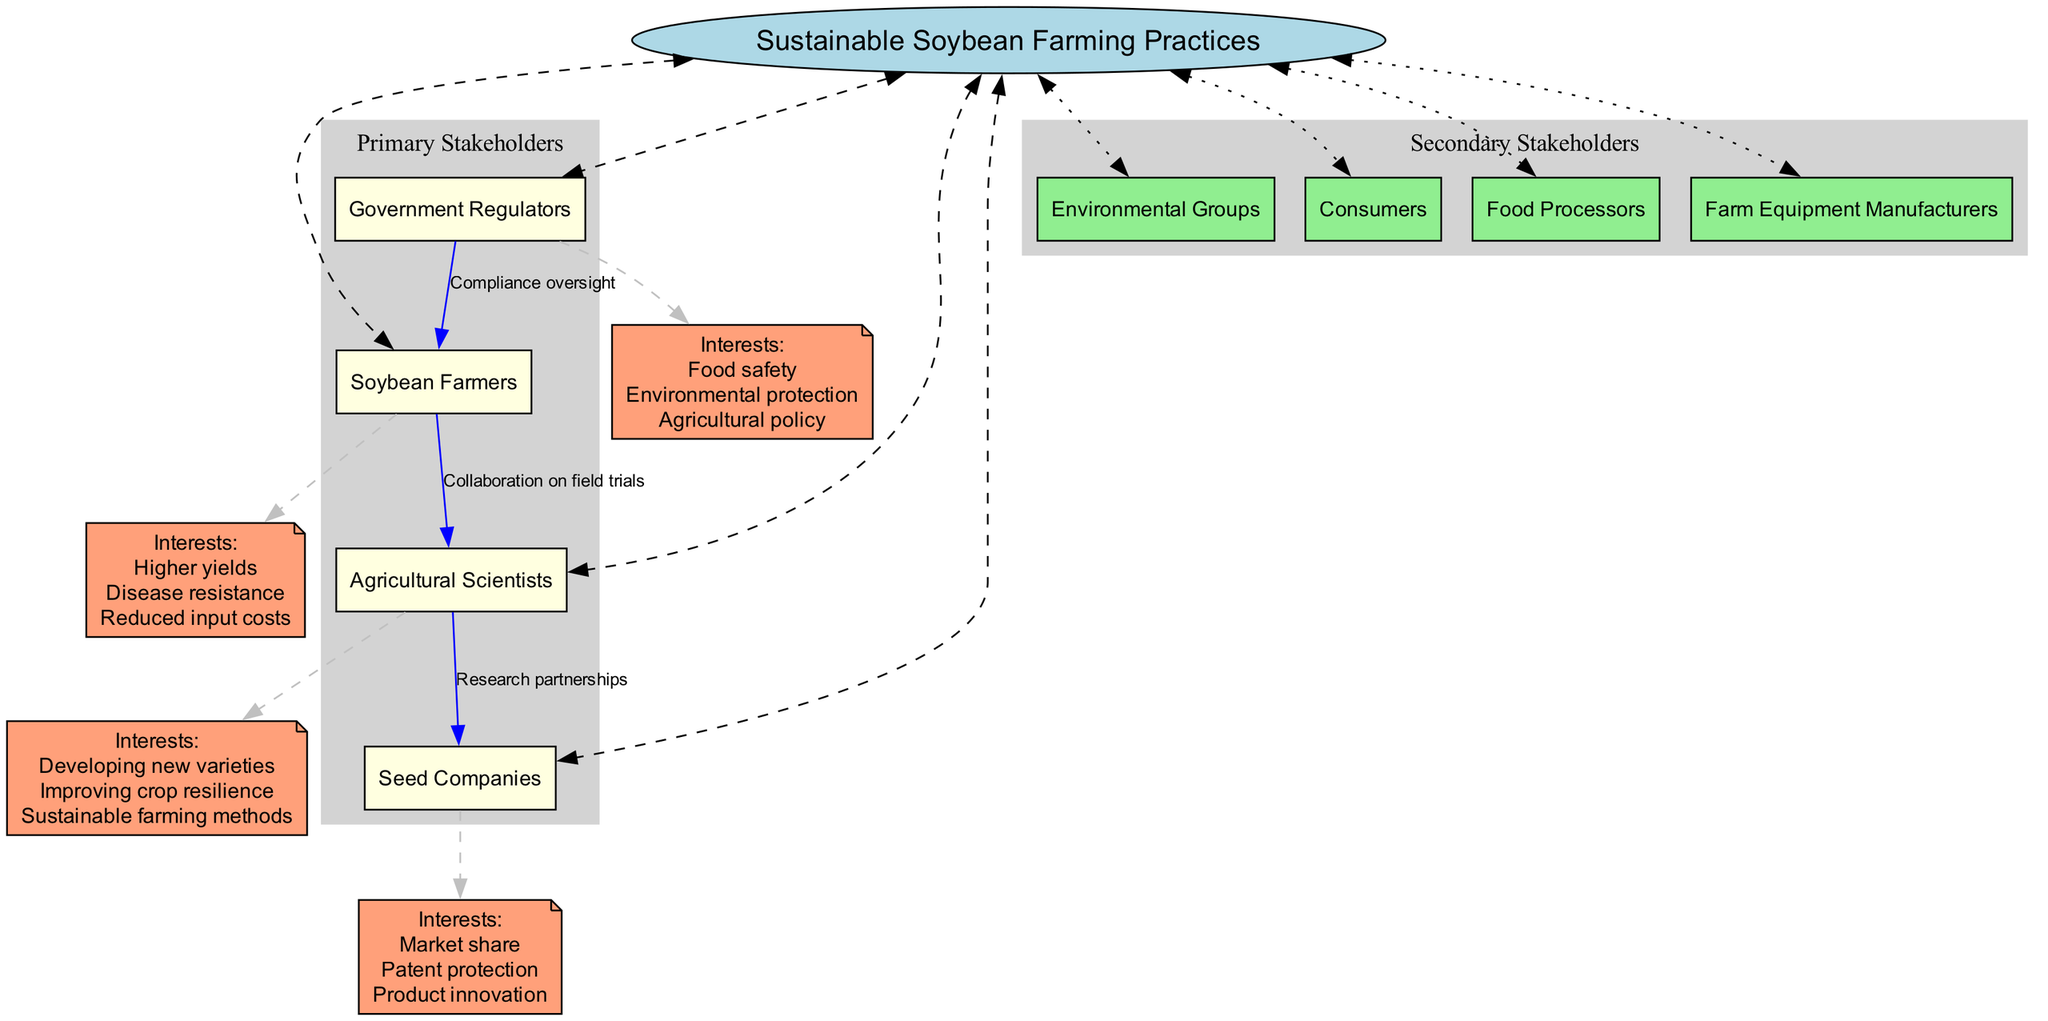What is the central topic of the diagram? The diagram clearly states that the central topic is "Sustainable Soybean Farming Practices", prominently displayed at the center of the diagram.
Answer: Sustainable Soybean Farming Practices How many primary stakeholders are listed? Counting the nodes in the "Primary Stakeholders" section, there are four stakeholders: Soybean Farmers, Agricultural Scientists, Seed Companies, and Government Regulators.
Answer: 4 What interests do Agricultural Scientists have? Looking at the interests linked to Agricultural Scientists, they are specified as: Developing new varieties, Improving crop resilience, and Sustainable farming methods.
Answer: Developing new varieties, Improving crop resilience, Sustainable farming methods What type of relationship exists between Government Regulators and Soybean Farmers? The diagram directly indicates that there is a relationship labeled "Compliance oversight" extending from Government Regulators to Soybean Farmers, which describes the nature of their interaction.
Answer: Compliance oversight Which secondary stakeholder is not directly connected to any primary stakeholder? In reviewing the diagram, Environmental Groups, Consumers, Food Processors, and Farm Equipment Manufacturers are in the "Secondary Stakeholders" section. None of these are shown to have direct relationships with any of the primary stakeholders, thus making them not directly connected.
Answer: All secondary stakeholders What is the relationship between Agricultural Scientists and Seed Companies? The diagram specifies a relationship labeled "Research partnerships" that connects Agricultural Scientists to Seed Companies, illustrating their collaborative efforts.
Answer: Research partnerships How many interests does Seed Companies have? The interests listed for Seed Companies include Market share, Patent protection, and Product innovation, making a total of three distinct interests.
Answer: 3 Which stakeholder is primarily interested in food safety? Among the list of interests by different stakeholders, Government Regulators specifically include "Food safety" as one of their main interests demonstrating their focus in this area.
Answer: Government Regulators What color is used for the interests nodes in the diagram? The interests nodes for each stakeholder are filled with 'lightsalmon' color, as defined in the diagram's attributes for node colors.
Answer: lightsalmon 